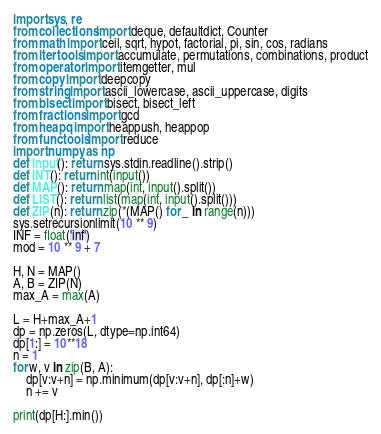<code> <loc_0><loc_0><loc_500><loc_500><_Python_>import sys, re
from collections import deque, defaultdict, Counter
from math import ceil, sqrt, hypot, factorial, pi, sin, cos, radians
from itertools import accumulate, permutations, combinations, product
from operator import itemgetter, mul
from copy import deepcopy
from string import ascii_lowercase, ascii_uppercase, digits
from bisect import bisect, bisect_left
from fractions import gcd
from heapq import heappush, heappop
from functools import reduce
import numpy as np
def input(): return sys.stdin.readline().strip()
def INT(): return int(input())
def MAP(): return map(int, input().split())
def LIST(): return list(map(int, input().split()))
def ZIP(n): return zip(*(MAP() for _ in range(n)))
sys.setrecursionlimit(10 ** 9)
INF = float('inf')
mod = 10 ** 9 + 7

H, N = MAP()
A, B = ZIP(N)
max_A = max(A)

L = H+max_A+1
dp = np.zeros(L, dtype=np.int64)
dp[1:] = 10**18
n = 1
for w, v in zip(B, A):
	dp[v:v+n] = np.minimum(dp[v:v+n], dp[:n]+w)
	n += v

print(dp[H:].min())
</code> 